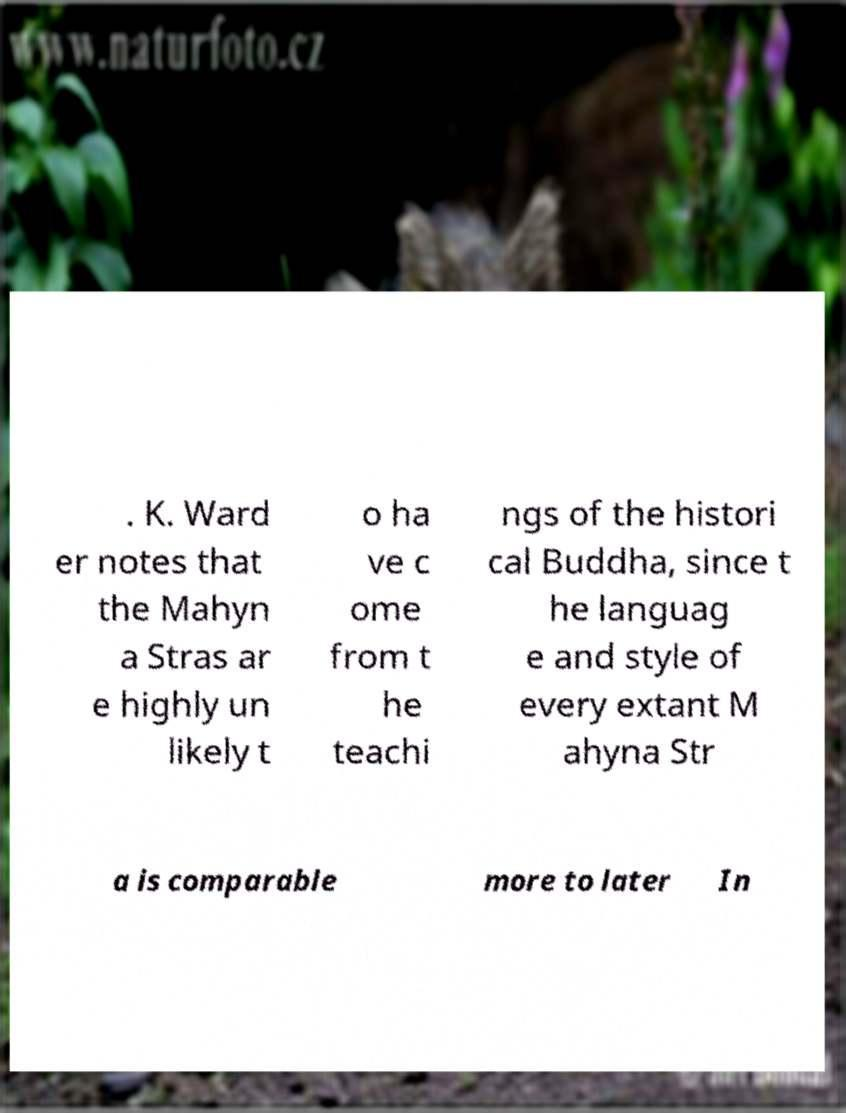Can you read and provide the text displayed in the image?This photo seems to have some interesting text. Can you extract and type it out for me? . K. Ward er notes that the Mahyn a Stras ar e highly un likely t o ha ve c ome from t he teachi ngs of the histori cal Buddha, since t he languag e and style of every extant M ahyna Str a is comparable more to later In 